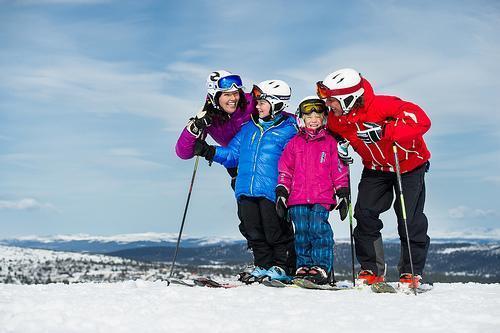How many people are there?
Give a very brief answer. 4. 